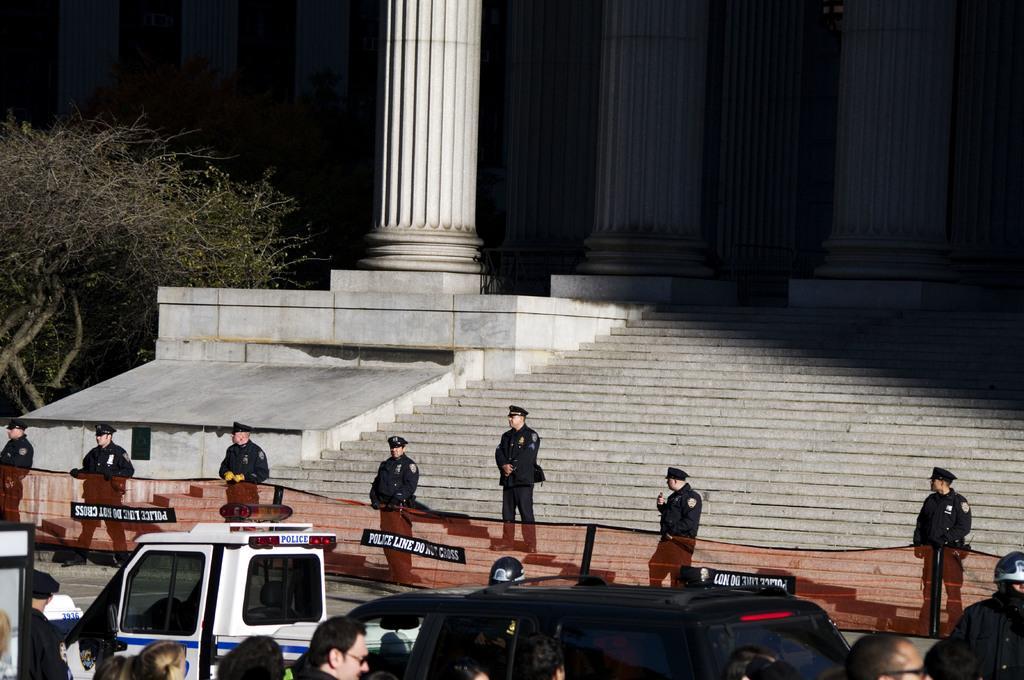Could you give a brief overview of what you see in this image? This picture is clicked outside. In the foreground we can see the group of persons and some vehicles. In the center we can see the group of persons wearing uniforms and standing on the ground and there is a red color net. In the background we can see the building and pillars and stairs of the building and we can see the tree. 